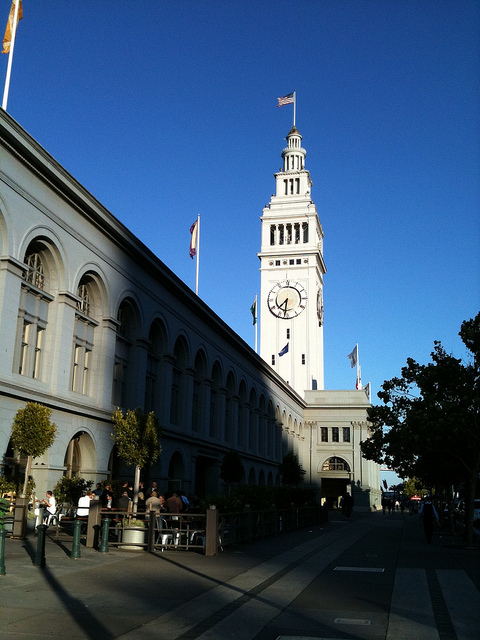<image>What color are the seats? I don't know what color the seats are. They could be white, black, brown or gray. What color are the seats? I am not sure what color the seats are. It can be seen white, black, brown, gray or none. 